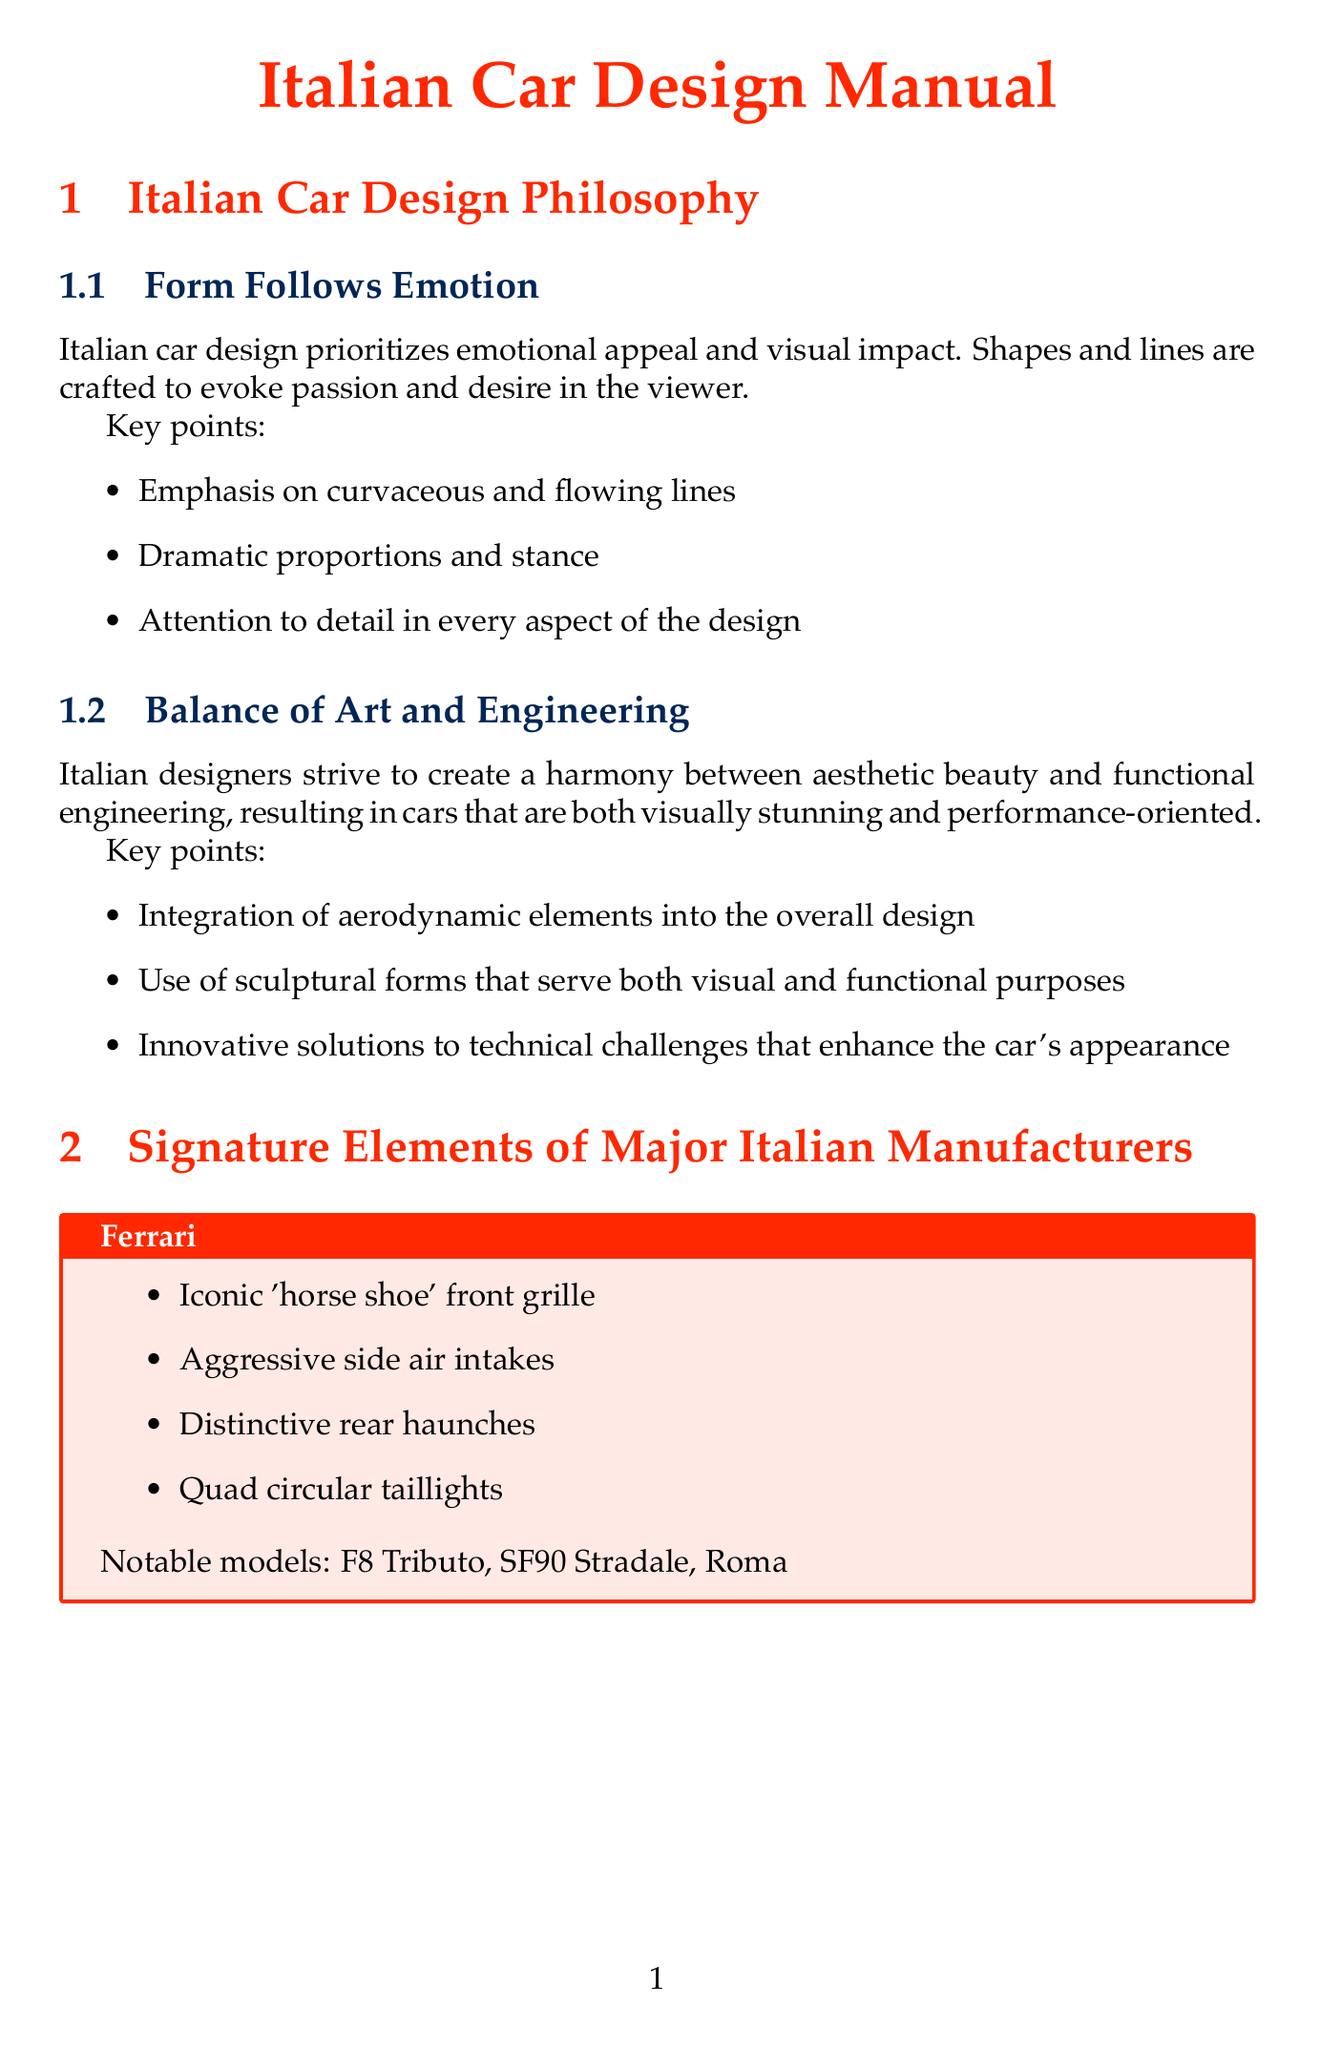What is the primary focus of Italian car design philosophy? The primary focus is on emotional appeal and visual impact, which aims to evoke passion and desire in the viewer.
Answer: Emotional appeal What signature element is unique to Ferrari? The iconic signature element associated with Ferrari is its distinctive front grille.
Answer: Horse shoe front grille What are the notable models of Lamborghini? The document lists specific models that exemplify Lamborghini's design.
Answer: Aventador, Huracán, Urus Which lighting technique emphasizes the curves of Italian car designs? The technique that specifically highlights the curves is the use of soft, diffused light.
Answer: Soft, diffused light What era is characterized by sharp, angular designs? The 1970s-1980s is known for sharp, angular designs in Italian car aesthetics.
Answer: The Wedge Era Who was a key designer during the Golden Age of Italian car design? The document lists prominent figures from this period, highlighting their influential contributions.
Answer: Battista Farina What is a key visual feature of Maserati's design? Maserati’s design features include a notable element that captures its aesthetic identity.
Answer: Trident logo Which photographic technique can be used to guide the viewer's eye? The technique that aids in guiding the viewer's attention visually is leading lines.
Answer: Leading lines 